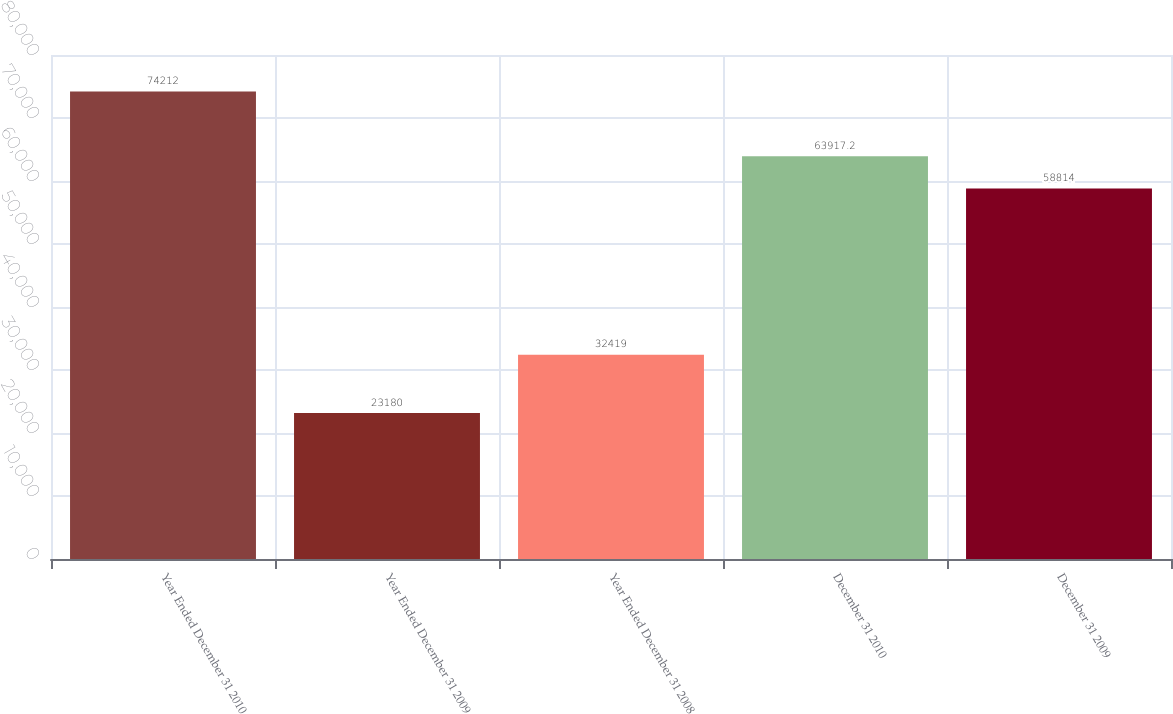Convert chart to OTSL. <chart><loc_0><loc_0><loc_500><loc_500><bar_chart><fcel>Year Ended December 31 2010<fcel>Year Ended December 31 2009<fcel>Year Ended December 31 2008<fcel>December 31 2010<fcel>December 31 2009<nl><fcel>74212<fcel>23180<fcel>32419<fcel>63917.2<fcel>58814<nl></chart> 